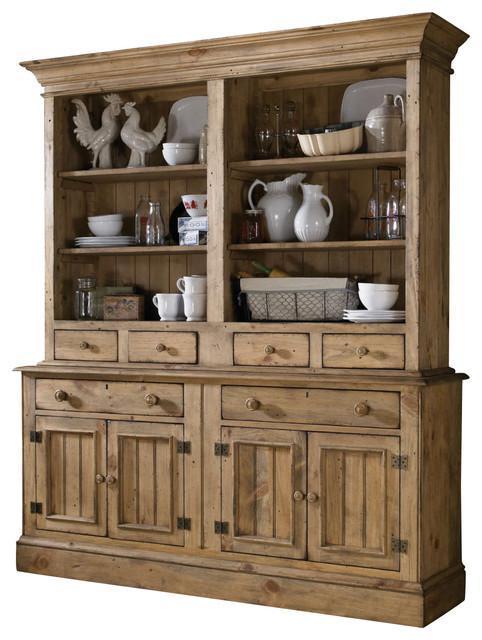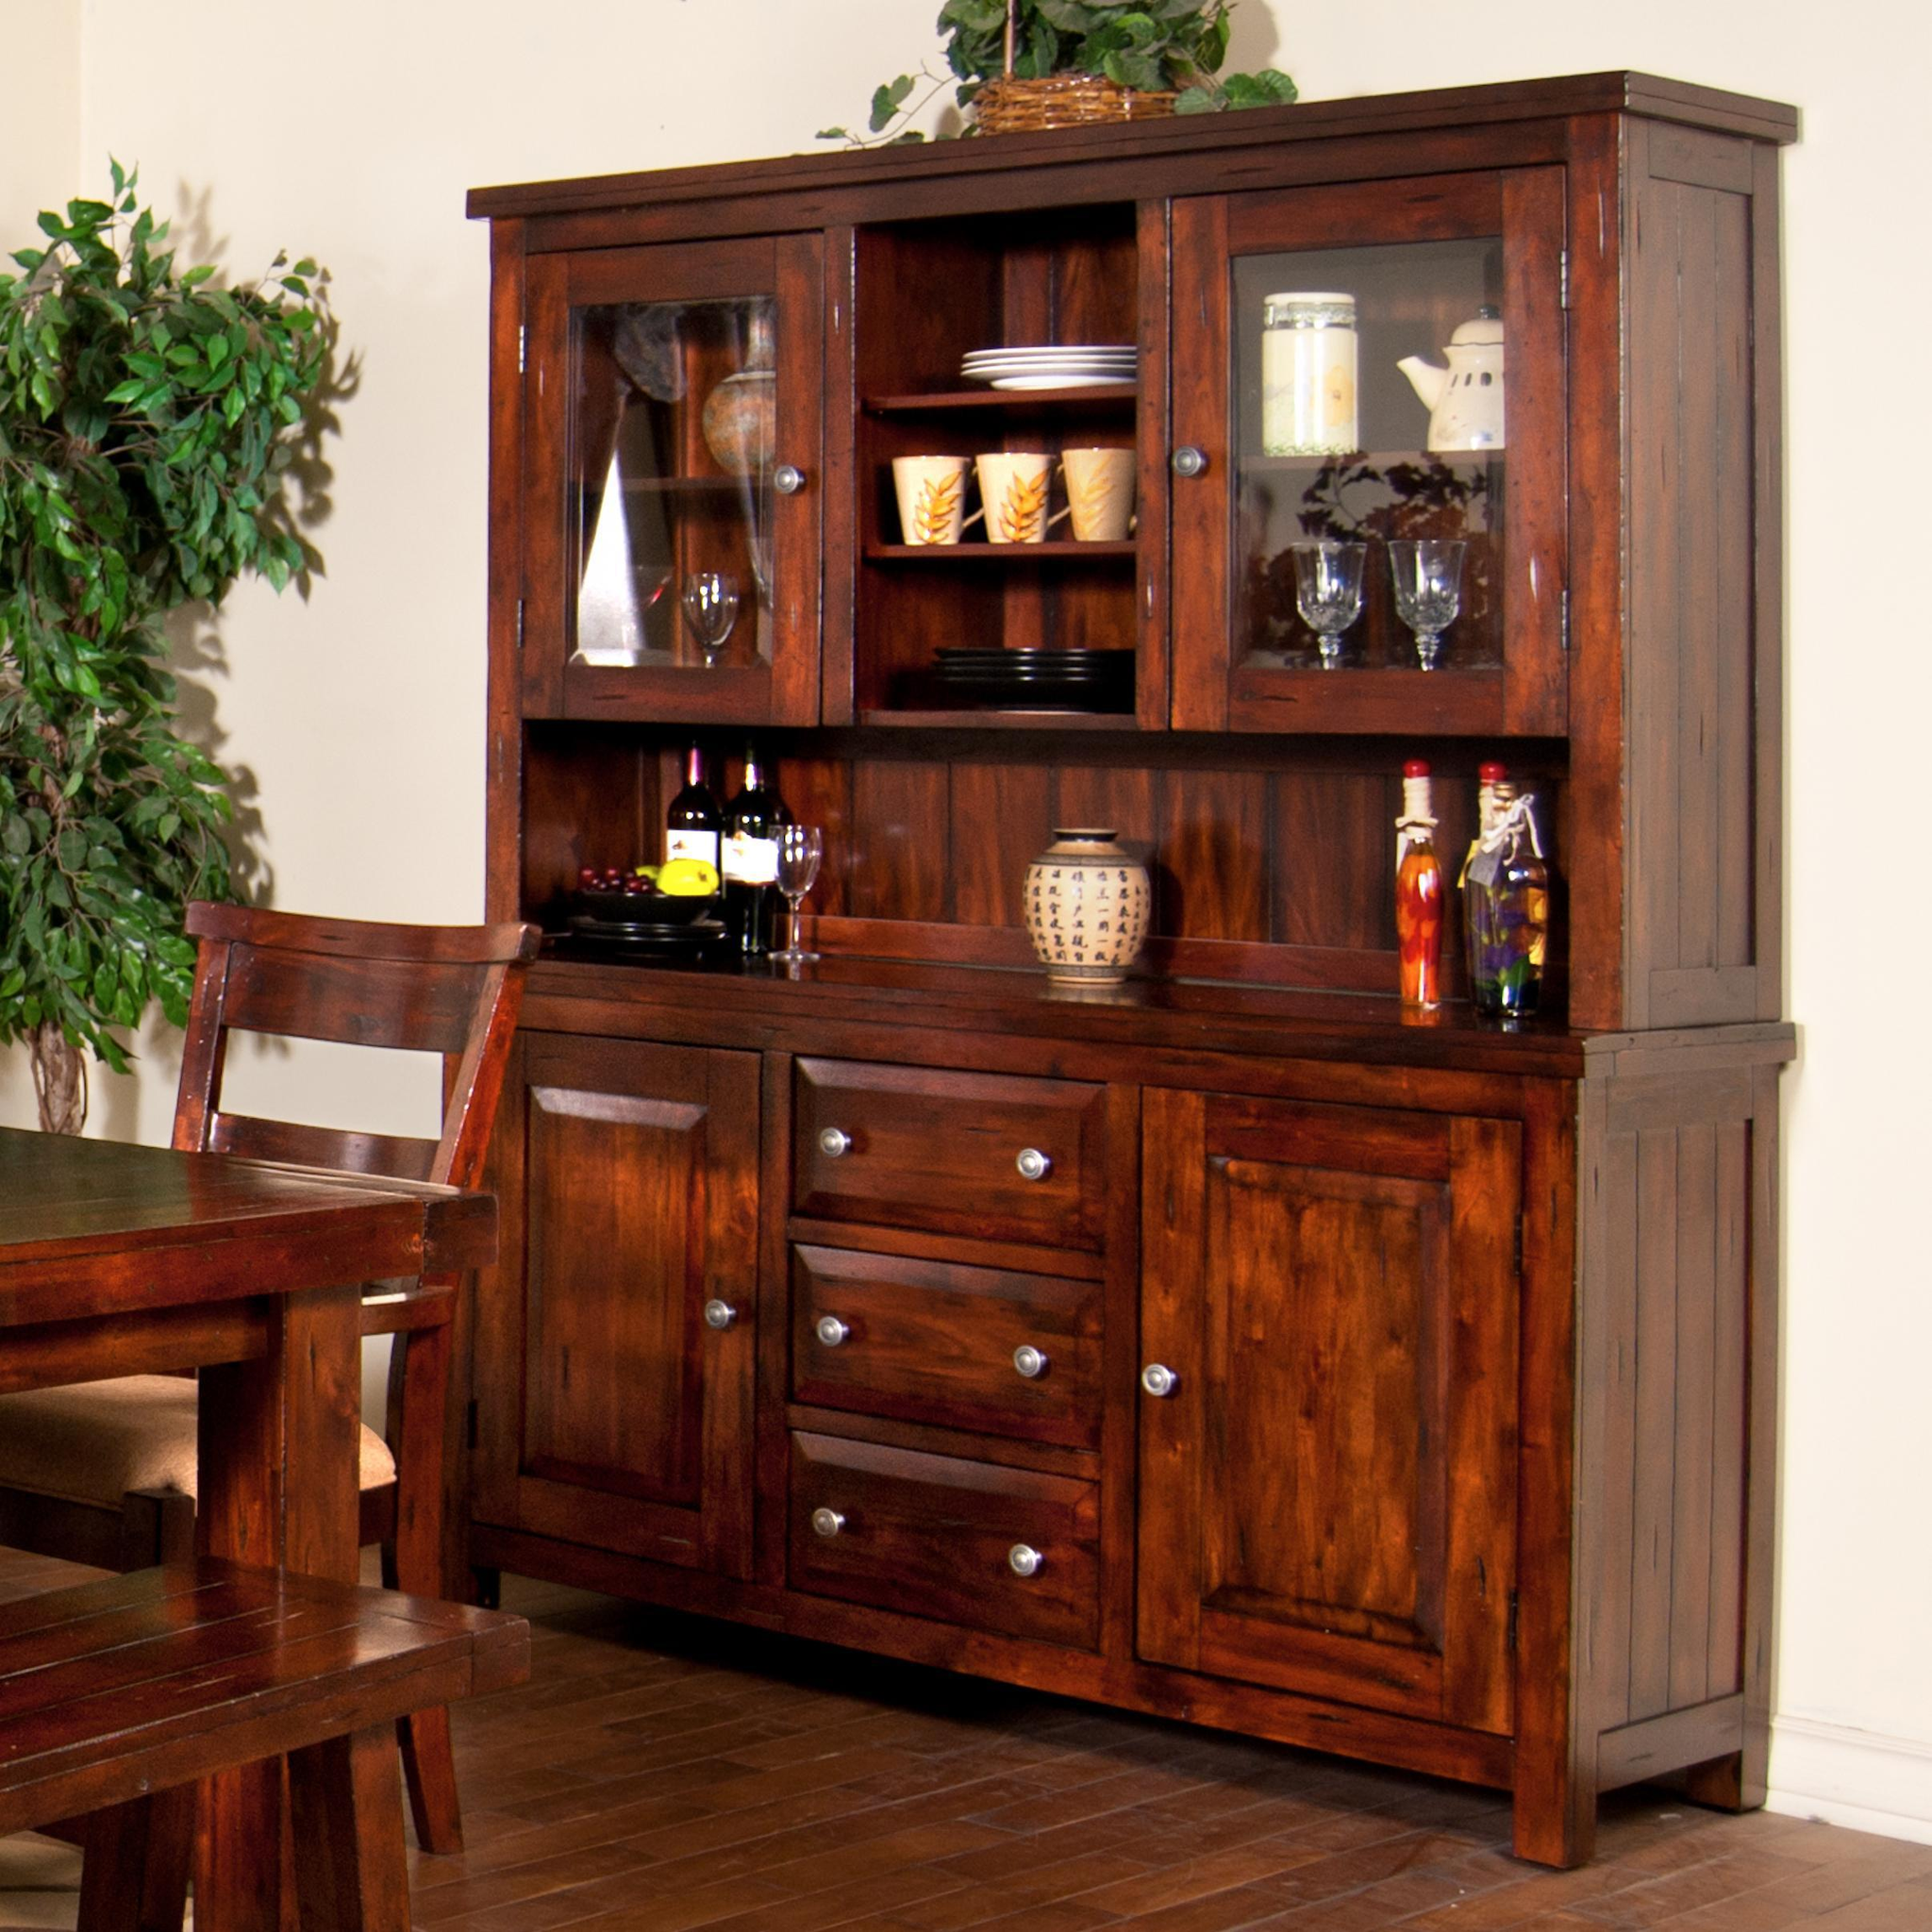The first image is the image on the left, the second image is the image on the right. Evaluate the accuracy of this statement regarding the images: "There are exactly three drawers on the cabinet in the image on the right.". Is it true? Answer yes or no. Yes. 